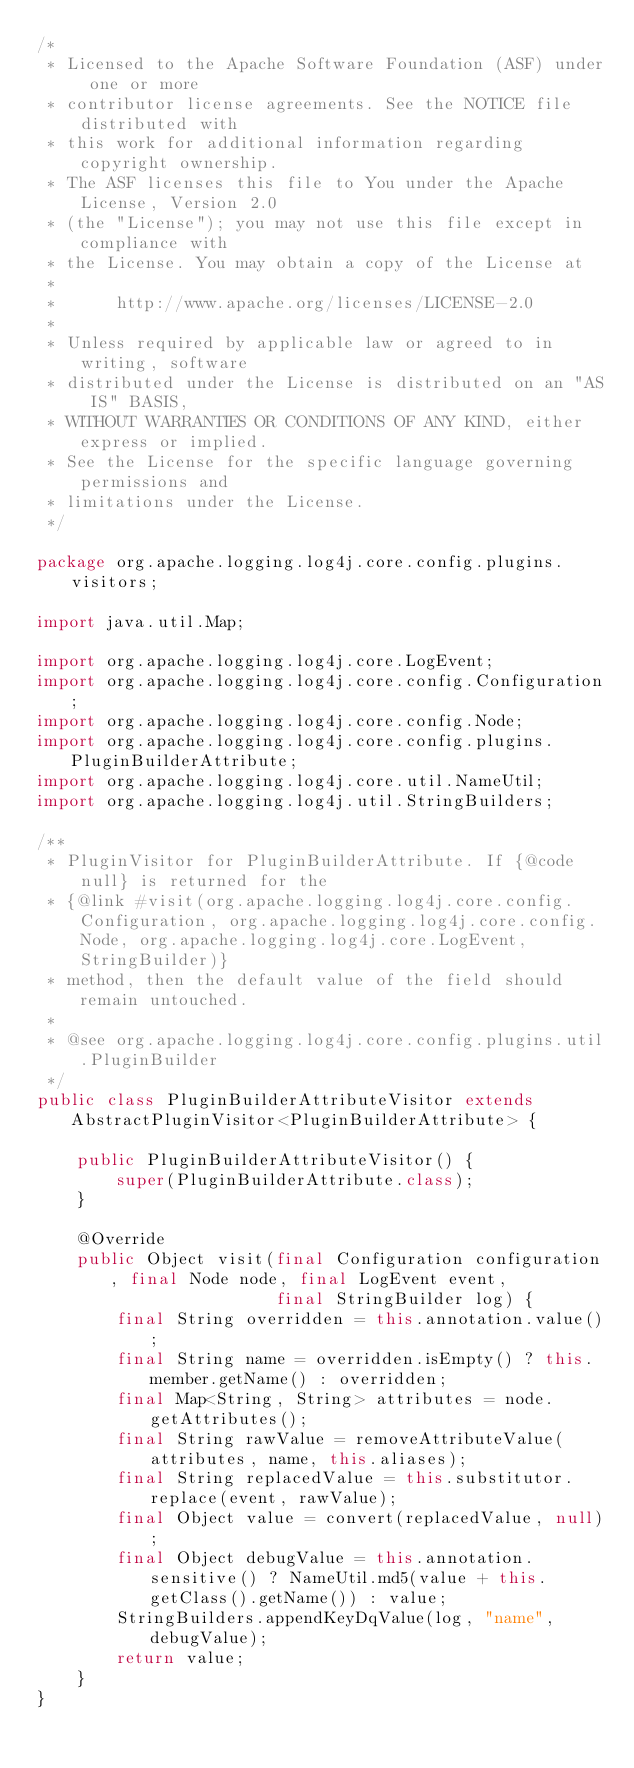Convert code to text. <code><loc_0><loc_0><loc_500><loc_500><_Java_>/*
 * Licensed to the Apache Software Foundation (ASF) under one or more
 * contributor license agreements. See the NOTICE file distributed with
 * this work for additional information regarding copyright ownership.
 * The ASF licenses this file to You under the Apache License, Version 2.0
 * (the "License"); you may not use this file except in compliance with
 * the License. You may obtain a copy of the License at
 *
 *      http://www.apache.org/licenses/LICENSE-2.0
 *
 * Unless required by applicable law or agreed to in writing, software
 * distributed under the License is distributed on an "AS IS" BASIS,
 * WITHOUT WARRANTIES OR CONDITIONS OF ANY KIND, either express or implied.
 * See the License for the specific language governing permissions and
 * limitations under the License.
 */

package org.apache.logging.log4j.core.config.plugins.visitors;

import java.util.Map;

import org.apache.logging.log4j.core.LogEvent;
import org.apache.logging.log4j.core.config.Configuration;
import org.apache.logging.log4j.core.config.Node;
import org.apache.logging.log4j.core.config.plugins.PluginBuilderAttribute;
import org.apache.logging.log4j.core.util.NameUtil;
import org.apache.logging.log4j.util.StringBuilders;

/**
 * PluginVisitor for PluginBuilderAttribute. If {@code null} is returned for the
 * {@link #visit(org.apache.logging.log4j.core.config.Configuration, org.apache.logging.log4j.core.config.Node, org.apache.logging.log4j.core.LogEvent, StringBuilder)}
 * method, then the default value of the field should remain untouched.
 *
 * @see org.apache.logging.log4j.core.config.plugins.util.PluginBuilder
 */
public class PluginBuilderAttributeVisitor extends AbstractPluginVisitor<PluginBuilderAttribute> {

    public PluginBuilderAttributeVisitor() {
        super(PluginBuilderAttribute.class);
    }

    @Override
    public Object visit(final Configuration configuration, final Node node, final LogEvent event,
                        final StringBuilder log) {
        final String overridden = this.annotation.value();
        final String name = overridden.isEmpty() ? this.member.getName() : overridden;
        final Map<String, String> attributes = node.getAttributes();
        final String rawValue = removeAttributeValue(attributes, name, this.aliases);
        final String replacedValue = this.substitutor.replace(event, rawValue);
        final Object value = convert(replacedValue, null);
        final Object debugValue = this.annotation.sensitive() ? NameUtil.md5(value + this.getClass().getName()) : value;
        StringBuilders.appendKeyDqValue(log, "name", debugValue);
        return value;
    }
}
</code> 